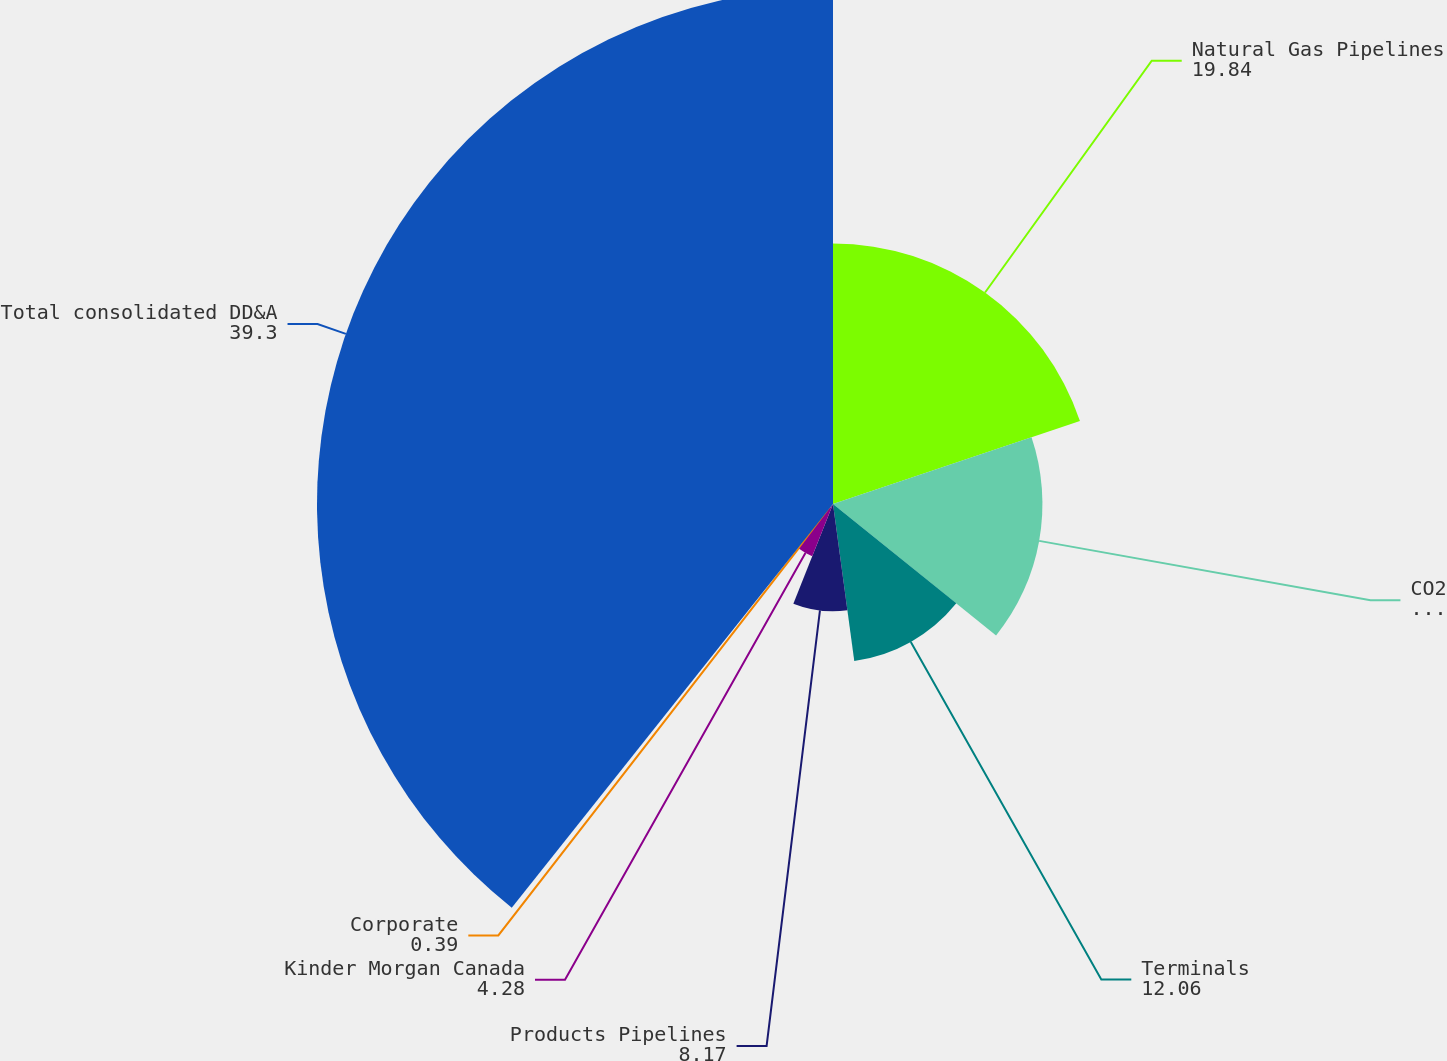Convert chart. <chart><loc_0><loc_0><loc_500><loc_500><pie_chart><fcel>Natural Gas Pipelines<fcel>CO2<fcel>Terminals<fcel>Products Pipelines<fcel>Kinder Morgan Canada<fcel>Corporate<fcel>Total consolidated DD&A<nl><fcel>19.84%<fcel>15.95%<fcel>12.06%<fcel>8.17%<fcel>4.28%<fcel>0.39%<fcel>39.3%<nl></chart> 